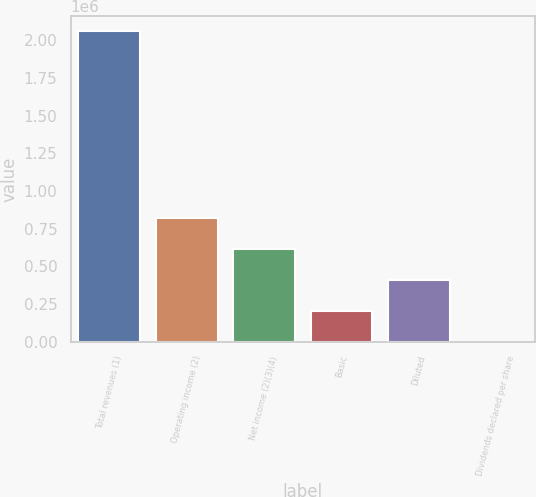Convert chart to OTSL. <chart><loc_0><loc_0><loc_500><loc_500><bar_chart><fcel>Total revenues (1)<fcel>Operating income (2)<fcel>Net income (2)(3)(4)<fcel>Basic<fcel>Diluted<fcel>Dividends declared per share<nl><fcel>2.05832e+06<fcel>823329<fcel>617497<fcel>205832<fcel>411665<fcel>0.3<nl></chart> 